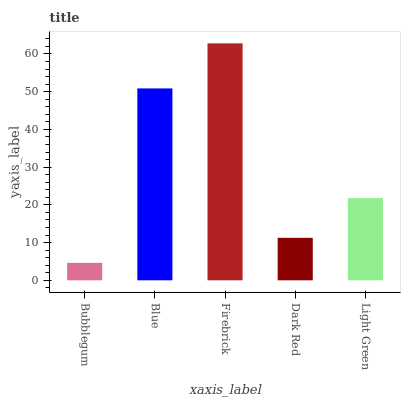Is Bubblegum the minimum?
Answer yes or no. Yes. Is Firebrick the maximum?
Answer yes or no. Yes. Is Blue the minimum?
Answer yes or no. No. Is Blue the maximum?
Answer yes or no. No. Is Blue greater than Bubblegum?
Answer yes or no. Yes. Is Bubblegum less than Blue?
Answer yes or no. Yes. Is Bubblegum greater than Blue?
Answer yes or no. No. Is Blue less than Bubblegum?
Answer yes or no. No. Is Light Green the high median?
Answer yes or no. Yes. Is Light Green the low median?
Answer yes or no. Yes. Is Blue the high median?
Answer yes or no. No. Is Blue the low median?
Answer yes or no. No. 